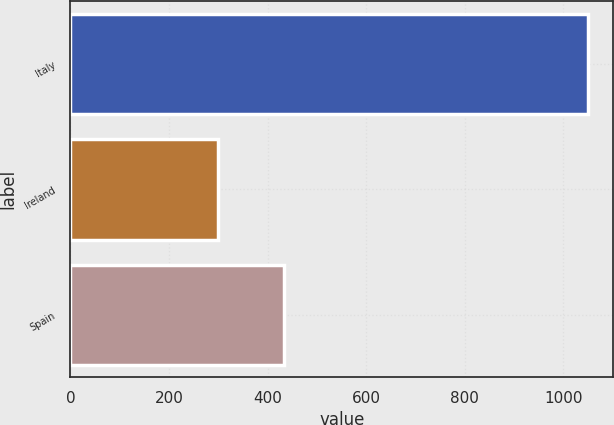Convert chart. <chart><loc_0><loc_0><loc_500><loc_500><bar_chart><fcel>Italy<fcel>Ireland<fcel>Spain<nl><fcel>1049<fcel>299<fcel>434<nl></chart> 